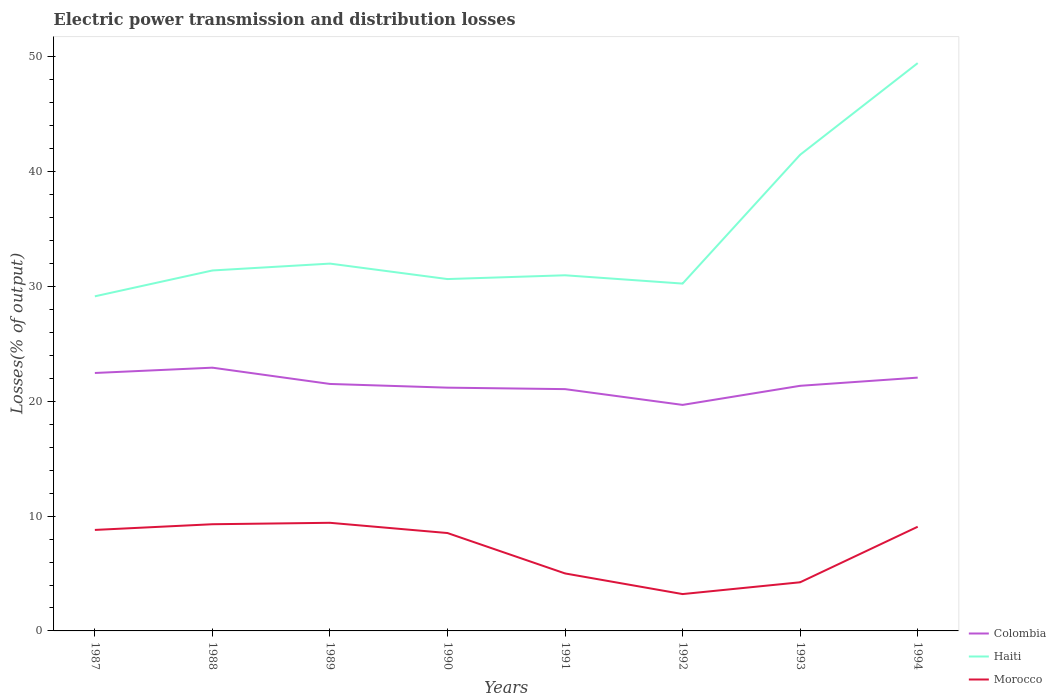Does the line corresponding to Morocco intersect with the line corresponding to Colombia?
Offer a terse response. No. Across all years, what is the maximum electric power transmission and distribution losses in Colombia?
Offer a terse response. 19.69. In which year was the electric power transmission and distribution losses in Haiti maximum?
Your answer should be compact. 1987. What is the total electric power transmission and distribution losses in Morocco in the graph?
Make the answer very short. 6.21. What is the difference between the highest and the second highest electric power transmission and distribution losses in Colombia?
Make the answer very short. 3.24. What is the difference between the highest and the lowest electric power transmission and distribution losses in Morocco?
Your answer should be compact. 5. Is the electric power transmission and distribution losses in Colombia strictly greater than the electric power transmission and distribution losses in Haiti over the years?
Ensure brevity in your answer.  Yes. How many lines are there?
Your answer should be compact. 3. How many years are there in the graph?
Provide a short and direct response. 8. What is the difference between two consecutive major ticks on the Y-axis?
Keep it short and to the point. 10. Are the values on the major ticks of Y-axis written in scientific E-notation?
Provide a short and direct response. No. How many legend labels are there?
Your answer should be very brief. 3. What is the title of the graph?
Your response must be concise. Electric power transmission and distribution losses. What is the label or title of the X-axis?
Ensure brevity in your answer.  Years. What is the label or title of the Y-axis?
Provide a short and direct response. Losses(% of output). What is the Losses(% of output) in Colombia in 1987?
Provide a succinct answer. 22.47. What is the Losses(% of output) of Haiti in 1987?
Offer a very short reply. 29.15. What is the Losses(% of output) of Morocco in 1987?
Your answer should be very brief. 8.8. What is the Losses(% of output) of Colombia in 1988?
Ensure brevity in your answer.  22.93. What is the Losses(% of output) in Haiti in 1988?
Ensure brevity in your answer.  31.4. What is the Losses(% of output) of Morocco in 1988?
Offer a very short reply. 9.29. What is the Losses(% of output) in Colombia in 1989?
Provide a succinct answer. 21.52. What is the Losses(% of output) of Haiti in 1989?
Keep it short and to the point. 32. What is the Losses(% of output) of Morocco in 1989?
Offer a terse response. 9.42. What is the Losses(% of output) of Colombia in 1990?
Offer a terse response. 21.19. What is the Losses(% of output) in Haiti in 1990?
Your answer should be very brief. 30.65. What is the Losses(% of output) in Morocco in 1990?
Provide a succinct answer. 8.53. What is the Losses(% of output) in Colombia in 1991?
Make the answer very short. 21.07. What is the Losses(% of output) of Haiti in 1991?
Provide a short and direct response. 30.98. What is the Losses(% of output) in Morocco in 1991?
Your answer should be very brief. 5.01. What is the Losses(% of output) in Colombia in 1992?
Your answer should be compact. 19.69. What is the Losses(% of output) of Haiti in 1992?
Keep it short and to the point. 30.26. What is the Losses(% of output) in Morocco in 1992?
Your answer should be compact. 3.21. What is the Losses(% of output) of Colombia in 1993?
Ensure brevity in your answer.  21.35. What is the Losses(% of output) in Haiti in 1993?
Your response must be concise. 41.48. What is the Losses(% of output) in Morocco in 1993?
Provide a short and direct response. 4.24. What is the Losses(% of output) in Colombia in 1994?
Your answer should be compact. 22.07. What is the Losses(% of output) of Haiti in 1994?
Provide a succinct answer. 49.47. What is the Losses(% of output) of Morocco in 1994?
Give a very brief answer. 9.08. Across all years, what is the maximum Losses(% of output) in Colombia?
Give a very brief answer. 22.93. Across all years, what is the maximum Losses(% of output) of Haiti?
Your answer should be compact. 49.47. Across all years, what is the maximum Losses(% of output) in Morocco?
Keep it short and to the point. 9.42. Across all years, what is the minimum Losses(% of output) of Colombia?
Your response must be concise. 19.69. Across all years, what is the minimum Losses(% of output) in Haiti?
Your answer should be very brief. 29.15. Across all years, what is the minimum Losses(% of output) of Morocco?
Provide a succinct answer. 3.21. What is the total Losses(% of output) of Colombia in the graph?
Your answer should be very brief. 172.29. What is the total Losses(% of output) of Haiti in the graph?
Give a very brief answer. 275.4. What is the total Losses(% of output) of Morocco in the graph?
Make the answer very short. 57.57. What is the difference between the Losses(% of output) in Colombia in 1987 and that in 1988?
Offer a very short reply. -0.46. What is the difference between the Losses(% of output) in Haiti in 1987 and that in 1988?
Your answer should be compact. -2.25. What is the difference between the Losses(% of output) in Morocco in 1987 and that in 1988?
Your answer should be compact. -0.5. What is the difference between the Losses(% of output) of Colombia in 1987 and that in 1989?
Offer a terse response. 0.96. What is the difference between the Losses(% of output) in Haiti in 1987 and that in 1989?
Make the answer very short. -2.85. What is the difference between the Losses(% of output) of Morocco in 1987 and that in 1989?
Keep it short and to the point. -0.62. What is the difference between the Losses(% of output) of Colombia in 1987 and that in 1990?
Provide a short and direct response. 1.28. What is the difference between the Losses(% of output) in Haiti in 1987 and that in 1990?
Offer a terse response. -1.5. What is the difference between the Losses(% of output) of Morocco in 1987 and that in 1990?
Provide a short and direct response. 0.27. What is the difference between the Losses(% of output) in Colombia in 1987 and that in 1991?
Ensure brevity in your answer.  1.41. What is the difference between the Losses(% of output) in Haiti in 1987 and that in 1991?
Provide a succinct answer. -1.83. What is the difference between the Losses(% of output) in Morocco in 1987 and that in 1991?
Make the answer very short. 3.79. What is the difference between the Losses(% of output) in Colombia in 1987 and that in 1992?
Give a very brief answer. 2.78. What is the difference between the Losses(% of output) in Haiti in 1987 and that in 1992?
Your response must be concise. -1.11. What is the difference between the Losses(% of output) in Morocco in 1987 and that in 1992?
Your answer should be compact. 5.59. What is the difference between the Losses(% of output) in Colombia in 1987 and that in 1993?
Keep it short and to the point. 1.12. What is the difference between the Losses(% of output) in Haiti in 1987 and that in 1993?
Make the answer very short. -12.33. What is the difference between the Losses(% of output) in Morocco in 1987 and that in 1993?
Your response must be concise. 4.56. What is the difference between the Losses(% of output) in Colombia in 1987 and that in 1994?
Offer a very short reply. 0.4. What is the difference between the Losses(% of output) of Haiti in 1987 and that in 1994?
Give a very brief answer. -20.32. What is the difference between the Losses(% of output) of Morocco in 1987 and that in 1994?
Ensure brevity in your answer.  -0.28. What is the difference between the Losses(% of output) in Colombia in 1988 and that in 1989?
Your answer should be compact. 1.42. What is the difference between the Losses(% of output) in Haiti in 1988 and that in 1989?
Your answer should be very brief. -0.6. What is the difference between the Losses(% of output) of Morocco in 1988 and that in 1989?
Provide a succinct answer. -0.12. What is the difference between the Losses(% of output) of Colombia in 1988 and that in 1990?
Provide a succinct answer. 1.74. What is the difference between the Losses(% of output) in Haiti in 1988 and that in 1990?
Offer a very short reply. 0.75. What is the difference between the Losses(% of output) of Morocco in 1988 and that in 1990?
Your response must be concise. 0.77. What is the difference between the Losses(% of output) of Colombia in 1988 and that in 1991?
Give a very brief answer. 1.87. What is the difference between the Losses(% of output) of Haiti in 1988 and that in 1991?
Your response must be concise. 0.42. What is the difference between the Losses(% of output) of Morocco in 1988 and that in 1991?
Keep it short and to the point. 4.29. What is the difference between the Losses(% of output) in Colombia in 1988 and that in 1992?
Make the answer very short. 3.24. What is the difference between the Losses(% of output) of Haiti in 1988 and that in 1992?
Your answer should be very brief. 1.14. What is the difference between the Losses(% of output) in Morocco in 1988 and that in 1992?
Provide a short and direct response. 6.08. What is the difference between the Losses(% of output) in Colombia in 1988 and that in 1993?
Your response must be concise. 1.58. What is the difference between the Losses(% of output) of Haiti in 1988 and that in 1993?
Your response must be concise. -10.08. What is the difference between the Losses(% of output) of Morocco in 1988 and that in 1993?
Offer a terse response. 5.06. What is the difference between the Losses(% of output) in Colombia in 1988 and that in 1994?
Offer a terse response. 0.87. What is the difference between the Losses(% of output) in Haiti in 1988 and that in 1994?
Give a very brief answer. -18.06. What is the difference between the Losses(% of output) in Morocco in 1988 and that in 1994?
Offer a very short reply. 0.22. What is the difference between the Losses(% of output) in Colombia in 1989 and that in 1990?
Give a very brief answer. 0.32. What is the difference between the Losses(% of output) of Haiti in 1989 and that in 1990?
Provide a short and direct response. 1.35. What is the difference between the Losses(% of output) in Morocco in 1989 and that in 1990?
Offer a very short reply. 0.89. What is the difference between the Losses(% of output) of Colombia in 1989 and that in 1991?
Your answer should be very brief. 0.45. What is the difference between the Losses(% of output) in Haiti in 1989 and that in 1991?
Your response must be concise. 1.02. What is the difference between the Losses(% of output) in Morocco in 1989 and that in 1991?
Make the answer very short. 4.41. What is the difference between the Losses(% of output) in Colombia in 1989 and that in 1992?
Offer a very short reply. 1.82. What is the difference between the Losses(% of output) of Haiti in 1989 and that in 1992?
Your response must be concise. 1.74. What is the difference between the Losses(% of output) of Morocco in 1989 and that in 1992?
Offer a terse response. 6.21. What is the difference between the Losses(% of output) in Colombia in 1989 and that in 1993?
Your answer should be compact. 0.16. What is the difference between the Losses(% of output) of Haiti in 1989 and that in 1993?
Ensure brevity in your answer.  -9.48. What is the difference between the Losses(% of output) in Morocco in 1989 and that in 1993?
Offer a terse response. 5.18. What is the difference between the Losses(% of output) in Colombia in 1989 and that in 1994?
Your answer should be very brief. -0.55. What is the difference between the Losses(% of output) of Haiti in 1989 and that in 1994?
Ensure brevity in your answer.  -17.47. What is the difference between the Losses(% of output) in Morocco in 1989 and that in 1994?
Keep it short and to the point. 0.34. What is the difference between the Losses(% of output) of Colombia in 1990 and that in 1991?
Offer a very short reply. 0.13. What is the difference between the Losses(% of output) of Haiti in 1990 and that in 1991?
Offer a very short reply. -0.33. What is the difference between the Losses(% of output) in Morocco in 1990 and that in 1991?
Provide a succinct answer. 3.52. What is the difference between the Losses(% of output) in Colombia in 1990 and that in 1992?
Make the answer very short. 1.5. What is the difference between the Losses(% of output) in Haiti in 1990 and that in 1992?
Provide a succinct answer. 0.39. What is the difference between the Losses(% of output) in Morocco in 1990 and that in 1992?
Make the answer very short. 5.32. What is the difference between the Losses(% of output) of Colombia in 1990 and that in 1993?
Provide a short and direct response. -0.16. What is the difference between the Losses(% of output) in Haiti in 1990 and that in 1993?
Provide a succinct answer. -10.83. What is the difference between the Losses(% of output) in Morocco in 1990 and that in 1993?
Ensure brevity in your answer.  4.29. What is the difference between the Losses(% of output) of Colombia in 1990 and that in 1994?
Make the answer very short. -0.88. What is the difference between the Losses(% of output) of Haiti in 1990 and that in 1994?
Provide a succinct answer. -18.81. What is the difference between the Losses(% of output) of Morocco in 1990 and that in 1994?
Offer a very short reply. -0.55. What is the difference between the Losses(% of output) of Colombia in 1991 and that in 1992?
Your answer should be very brief. 1.37. What is the difference between the Losses(% of output) in Haiti in 1991 and that in 1992?
Give a very brief answer. 0.72. What is the difference between the Losses(% of output) of Morocco in 1991 and that in 1992?
Your response must be concise. 1.8. What is the difference between the Losses(% of output) of Colombia in 1991 and that in 1993?
Your response must be concise. -0.29. What is the difference between the Losses(% of output) of Haiti in 1991 and that in 1993?
Provide a succinct answer. -10.5. What is the difference between the Losses(% of output) in Morocco in 1991 and that in 1993?
Make the answer very short. 0.77. What is the difference between the Losses(% of output) of Colombia in 1991 and that in 1994?
Make the answer very short. -1. What is the difference between the Losses(% of output) of Haiti in 1991 and that in 1994?
Your response must be concise. -18.48. What is the difference between the Losses(% of output) in Morocco in 1991 and that in 1994?
Your answer should be very brief. -4.07. What is the difference between the Losses(% of output) of Colombia in 1992 and that in 1993?
Your answer should be compact. -1.66. What is the difference between the Losses(% of output) in Haiti in 1992 and that in 1993?
Your response must be concise. -11.22. What is the difference between the Losses(% of output) of Morocco in 1992 and that in 1993?
Offer a terse response. -1.03. What is the difference between the Losses(% of output) of Colombia in 1992 and that in 1994?
Offer a very short reply. -2.38. What is the difference between the Losses(% of output) in Haiti in 1992 and that in 1994?
Keep it short and to the point. -19.21. What is the difference between the Losses(% of output) in Morocco in 1992 and that in 1994?
Offer a very short reply. -5.87. What is the difference between the Losses(% of output) of Colombia in 1993 and that in 1994?
Offer a terse response. -0.71. What is the difference between the Losses(% of output) of Haiti in 1993 and that in 1994?
Provide a short and direct response. -7.98. What is the difference between the Losses(% of output) of Morocco in 1993 and that in 1994?
Provide a short and direct response. -4.84. What is the difference between the Losses(% of output) in Colombia in 1987 and the Losses(% of output) in Haiti in 1988?
Your response must be concise. -8.93. What is the difference between the Losses(% of output) of Colombia in 1987 and the Losses(% of output) of Morocco in 1988?
Your response must be concise. 13.18. What is the difference between the Losses(% of output) of Haiti in 1987 and the Losses(% of output) of Morocco in 1988?
Your answer should be compact. 19.86. What is the difference between the Losses(% of output) in Colombia in 1987 and the Losses(% of output) in Haiti in 1989?
Make the answer very short. -9.53. What is the difference between the Losses(% of output) in Colombia in 1987 and the Losses(% of output) in Morocco in 1989?
Offer a terse response. 13.05. What is the difference between the Losses(% of output) of Haiti in 1987 and the Losses(% of output) of Morocco in 1989?
Your response must be concise. 19.73. What is the difference between the Losses(% of output) in Colombia in 1987 and the Losses(% of output) in Haiti in 1990?
Ensure brevity in your answer.  -8.18. What is the difference between the Losses(% of output) in Colombia in 1987 and the Losses(% of output) in Morocco in 1990?
Provide a short and direct response. 13.94. What is the difference between the Losses(% of output) of Haiti in 1987 and the Losses(% of output) of Morocco in 1990?
Make the answer very short. 20.62. What is the difference between the Losses(% of output) in Colombia in 1987 and the Losses(% of output) in Haiti in 1991?
Offer a terse response. -8.51. What is the difference between the Losses(% of output) in Colombia in 1987 and the Losses(% of output) in Morocco in 1991?
Offer a terse response. 17.46. What is the difference between the Losses(% of output) of Haiti in 1987 and the Losses(% of output) of Morocco in 1991?
Provide a succinct answer. 24.14. What is the difference between the Losses(% of output) in Colombia in 1987 and the Losses(% of output) in Haiti in 1992?
Provide a succinct answer. -7.79. What is the difference between the Losses(% of output) in Colombia in 1987 and the Losses(% of output) in Morocco in 1992?
Offer a very short reply. 19.26. What is the difference between the Losses(% of output) in Haiti in 1987 and the Losses(% of output) in Morocco in 1992?
Ensure brevity in your answer.  25.94. What is the difference between the Losses(% of output) of Colombia in 1987 and the Losses(% of output) of Haiti in 1993?
Your answer should be very brief. -19.01. What is the difference between the Losses(% of output) of Colombia in 1987 and the Losses(% of output) of Morocco in 1993?
Ensure brevity in your answer.  18.23. What is the difference between the Losses(% of output) in Haiti in 1987 and the Losses(% of output) in Morocco in 1993?
Give a very brief answer. 24.91. What is the difference between the Losses(% of output) of Colombia in 1987 and the Losses(% of output) of Haiti in 1994?
Ensure brevity in your answer.  -26.99. What is the difference between the Losses(% of output) of Colombia in 1987 and the Losses(% of output) of Morocco in 1994?
Provide a short and direct response. 13.4. What is the difference between the Losses(% of output) in Haiti in 1987 and the Losses(% of output) in Morocco in 1994?
Offer a terse response. 20.07. What is the difference between the Losses(% of output) of Colombia in 1988 and the Losses(% of output) of Haiti in 1989?
Ensure brevity in your answer.  -9.07. What is the difference between the Losses(% of output) of Colombia in 1988 and the Losses(% of output) of Morocco in 1989?
Offer a very short reply. 13.51. What is the difference between the Losses(% of output) of Haiti in 1988 and the Losses(% of output) of Morocco in 1989?
Provide a succinct answer. 21.98. What is the difference between the Losses(% of output) of Colombia in 1988 and the Losses(% of output) of Haiti in 1990?
Your response must be concise. -7.72. What is the difference between the Losses(% of output) of Colombia in 1988 and the Losses(% of output) of Morocco in 1990?
Offer a very short reply. 14.41. What is the difference between the Losses(% of output) of Haiti in 1988 and the Losses(% of output) of Morocco in 1990?
Provide a succinct answer. 22.87. What is the difference between the Losses(% of output) in Colombia in 1988 and the Losses(% of output) in Haiti in 1991?
Offer a terse response. -8.05. What is the difference between the Losses(% of output) of Colombia in 1988 and the Losses(% of output) of Morocco in 1991?
Keep it short and to the point. 17.93. What is the difference between the Losses(% of output) of Haiti in 1988 and the Losses(% of output) of Morocco in 1991?
Keep it short and to the point. 26.39. What is the difference between the Losses(% of output) in Colombia in 1988 and the Losses(% of output) in Haiti in 1992?
Your response must be concise. -7.33. What is the difference between the Losses(% of output) in Colombia in 1988 and the Losses(% of output) in Morocco in 1992?
Ensure brevity in your answer.  19.72. What is the difference between the Losses(% of output) in Haiti in 1988 and the Losses(% of output) in Morocco in 1992?
Keep it short and to the point. 28.19. What is the difference between the Losses(% of output) in Colombia in 1988 and the Losses(% of output) in Haiti in 1993?
Provide a succinct answer. -18.55. What is the difference between the Losses(% of output) of Colombia in 1988 and the Losses(% of output) of Morocco in 1993?
Your answer should be compact. 18.7. What is the difference between the Losses(% of output) of Haiti in 1988 and the Losses(% of output) of Morocco in 1993?
Offer a terse response. 27.16. What is the difference between the Losses(% of output) of Colombia in 1988 and the Losses(% of output) of Haiti in 1994?
Your answer should be very brief. -26.53. What is the difference between the Losses(% of output) of Colombia in 1988 and the Losses(% of output) of Morocco in 1994?
Keep it short and to the point. 13.86. What is the difference between the Losses(% of output) in Haiti in 1988 and the Losses(% of output) in Morocco in 1994?
Provide a short and direct response. 22.33. What is the difference between the Losses(% of output) of Colombia in 1989 and the Losses(% of output) of Haiti in 1990?
Provide a succinct answer. -9.14. What is the difference between the Losses(% of output) in Colombia in 1989 and the Losses(% of output) in Morocco in 1990?
Your answer should be compact. 12.99. What is the difference between the Losses(% of output) in Haiti in 1989 and the Losses(% of output) in Morocco in 1990?
Your response must be concise. 23.47. What is the difference between the Losses(% of output) of Colombia in 1989 and the Losses(% of output) of Haiti in 1991?
Offer a very short reply. -9.47. What is the difference between the Losses(% of output) of Colombia in 1989 and the Losses(% of output) of Morocco in 1991?
Provide a short and direct response. 16.51. What is the difference between the Losses(% of output) in Haiti in 1989 and the Losses(% of output) in Morocco in 1991?
Keep it short and to the point. 26.99. What is the difference between the Losses(% of output) in Colombia in 1989 and the Losses(% of output) in Haiti in 1992?
Keep it short and to the point. -8.74. What is the difference between the Losses(% of output) in Colombia in 1989 and the Losses(% of output) in Morocco in 1992?
Provide a short and direct response. 18.31. What is the difference between the Losses(% of output) of Haiti in 1989 and the Losses(% of output) of Morocco in 1992?
Offer a very short reply. 28.79. What is the difference between the Losses(% of output) of Colombia in 1989 and the Losses(% of output) of Haiti in 1993?
Your answer should be compact. -19.97. What is the difference between the Losses(% of output) of Colombia in 1989 and the Losses(% of output) of Morocco in 1993?
Your answer should be compact. 17.28. What is the difference between the Losses(% of output) of Haiti in 1989 and the Losses(% of output) of Morocco in 1993?
Your answer should be very brief. 27.76. What is the difference between the Losses(% of output) of Colombia in 1989 and the Losses(% of output) of Haiti in 1994?
Give a very brief answer. -27.95. What is the difference between the Losses(% of output) of Colombia in 1989 and the Losses(% of output) of Morocco in 1994?
Your response must be concise. 12.44. What is the difference between the Losses(% of output) in Haiti in 1989 and the Losses(% of output) in Morocco in 1994?
Offer a terse response. 22.92. What is the difference between the Losses(% of output) of Colombia in 1990 and the Losses(% of output) of Haiti in 1991?
Give a very brief answer. -9.79. What is the difference between the Losses(% of output) in Colombia in 1990 and the Losses(% of output) in Morocco in 1991?
Ensure brevity in your answer.  16.18. What is the difference between the Losses(% of output) of Haiti in 1990 and the Losses(% of output) of Morocco in 1991?
Provide a short and direct response. 25.65. What is the difference between the Losses(% of output) of Colombia in 1990 and the Losses(% of output) of Haiti in 1992?
Provide a short and direct response. -9.07. What is the difference between the Losses(% of output) of Colombia in 1990 and the Losses(% of output) of Morocco in 1992?
Offer a very short reply. 17.98. What is the difference between the Losses(% of output) in Haiti in 1990 and the Losses(% of output) in Morocco in 1992?
Offer a very short reply. 27.44. What is the difference between the Losses(% of output) of Colombia in 1990 and the Losses(% of output) of Haiti in 1993?
Make the answer very short. -20.29. What is the difference between the Losses(% of output) in Colombia in 1990 and the Losses(% of output) in Morocco in 1993?
Make the answer very short. 16.95. What is the difference between the Losses(% of output) in Haiti in 1990 and the Losses(% of output) in Morocco in 1993?
Your answer should be compact. 26.42. What is the difference between the Losses(% of output) in Colombia in 1990 and the Losses(% of output) in Haiti in 1994?
Provide a short and direct response. -28.27. What is the difference between the Losses(% of output) in Colombia in 1990 and the Losses(% of output) in Morocco in 1994?
Provide a short and direct response. 12.12. What is the difference between the Losses(% of output) of Haiti in 1990 and the Losses(% of output) of Morocco in 1994?
Offer a terse response. 21.58. What is the difference between the Losses(% of output) of Colombia in 1991 and the Losses(% of output) of Haiti in 1992?
Your answer should be compact. -9.19. What is the difference between the Losses(% of output) of Colombia in 1991 and the Losses(% of output) of Morocco in 1992?
Offer a very short reply. 17.85. What is the difference between the Losses(% of output) in Haiti in 1991 and the Losses(% of output) in Morocco in 1992?
Your answer should be very brief. 27.77. What is the difference between the Losses(% of output) of Colombia in 1991 and the Losses(% of output) of Haiti in 1993?
Offer a terse response. -20.42. What is the difference between the Losses(% of output) in Colombia in 1991 and the Losses(% of output) in Morocco in 1993?
Make the answer very short. 16.83. What is the difference between the Losses(% of output) of Haiti in 1991 and the Losses(% of output) of Morocco in 1993?
Your answer should be compact. 26.74. What is the difference between the Losses(% of output) in Colombia in 1991 and the Losses(% of output) in Haiti in 1994?
Give a very brief answer. -28.4. What is the difference between the Losses(% of output) of Colombia in 1991 and the Losses(% of output) of Morocco in 1994?
Make the answer very short. 11.99. What is the difference between the Losses(% of output) of Haiti in 1991 and the Losses(% of output) of Morocco in 1994?
Ensure brevity in your answer.  21.91. What is the difference between the Losses(% of output) of Colombia in 1992 and the Losses(% of output) of Haiti in 1993?
Offer a very short reply. -21.79. What is the difference between the Losses(% of output) of Colombia in 1992 and the Losses(% of output) of Morocco in 1993?
Offer a very short reply. 15.45. What is the difference between the Losses(% of output) of Haiti in 1992 and the Losses(% of output) of Morocco in 1993?
Make the answer very short. 26.02. What is the difference between the Losses(% of output) of Colombia in 1992 and the Losses(% of output) of Haiti in 1994?
Your answer should be very brief. -29.78. What is the difference between the Losses(% of output) in Colombia in 1992 and the Losses(% of output) in Morocco in 1994?
Give a very brief answer. 10.62. What is the difference between the Losses(% of output) in Haiti in 1992 and the Losses(% of output) in Morocco in 1994?
Your answer should be compact. 21.18. What is the difference between the Losses(% of output) of Colombia in 1993 and the Losses(% of output) of Haiti in 1994?
Your answer should be compact. -28.11. What is the difference between the Losses(% of output) in Colombia in 1993 and the Losses(% of output) in Morocco in 1994?
Your response must be concise. 12.28. What is the difference between the Losses(% of output) in Haiti in 1993 and the Losses(% of output) in Morocco in 1994?
Make the answer very short. 32.41. What is the average Losses(% of output) of Colombia per year?
Offer a terse response. 21.54. What is the average Losses(% of output) of Haiti per year?
Provide a succinct answer. 34.42. What is the average Losses(% of output) of Morocco per year?
Offer a terse response. 7.2. In the year 1987, what is the difference between the Losses(% of output) in Colombia and Losses(% of output) in Haiti?
Give a very brief answer. -6.68. In the year 1987, what is the difference between the Losses(% of output) of Colombia and Losses(% of output) of Morocco?
Your answer should be very brief. 13.67. In the year 1987, what is the difference between the Losses(% of output) of Haiti and Losses(% of output) of Morocco?
Offer a very short reply. 20.35. In the year 1988, what is the difference between the Losses(% of output) of Colombia and Losses(% of output) of Haiti?
Provide a succinct answer. -8.47. In the year 1988, what is the difference between the Losses(% of output) of Colombia and Losses(% of output) of Morocco?
Offer a very short reply. 13.64. In the year 1988, what is the difference between the Losses(% of output) in Haiti and Losses(% of output) in Morocco?
Ensure brevity in your answer.  22.11. In the year 1989, what is the difference between the Losses(% of output) of Colombia and Losses(% of output) of Haiti?
Offer a terse response. -10.48. In the year 1989, what is the difference between the Losses(% of output) in Colombia and Losses(% of output) in Morocco?
Your response must be concise. 12.1. In the year 1989, what is the difference between the Losses(% of output) in Haiti and Losses(% of output) in Morocco?
Provide a succinct answer. 22.58. In the year 1990, what is the difference between the Losses(% of output) of Colombia and Losses(% of output) of Haiti?
Make the answer very short. -9.46. In the year 1990, what is the difference between the Losses(% of output) in Colombia and Losses(% of output) in Morocco?
Provide a succinct answer. 12.67. In the year 1990, what is the difference between the Losses(% of output) in Haiti and Losses(% of output) in Morocco?
Provide a succinct answer. 22.13. In the year 1991, what is the difference between the Losses(% of output) in Colombia and Losses(% of output) in Haiti?
Your response must be concise. -9.92. In the year 1991, what is the difference between the Losses(% of output) of Colombia and Losses(% of output) of Morocco?
Your answer should be very brief. 16.06. In the year 1991, what is the difference between the Losses(% of output) of Haiti and Losses(% of output) of Morocco?
Make the answer very short. 25.97. In the year 1992, what is the difference between the Losses(% of output) in Colombia and Losses(% of output) in Haiti?
Your answer should be very brief. -10.57. In the year 1992, what is the difference between the Losses(% of output) in Colombia and Losses(% of output) in Morocco?
Your response must be concise. 16.48. In the year 1992, what is the difference between the Losses(% of output) in Haiti and Losses(% of output) in Morocco?
Your answer should be compact. 27.05. In the year 1993, what is the difference between the Losses(% of output) in Colombia and Losses(% of output) in Haiti?
Provide a short and direct response. -20.13. In the year 1993, what is the difference between the Losses(% of output) in Colombia and Losses(% of output) in Morocco?
Your answer should be very brief. 17.12. In the year 1993, what is the difference between the Losses(% of output) in Haiti and Losses(% of output) in Morocco?
Ensure brevity in your answer.  37.25. In the year 1994, what is the difference between the Losses(% of output) in Colombia and Losses(% of output) in Haiti?
Provide a short and direct response. -27.4. In the year 1994, what is the difference between the Losses(% of output) in Colombia and Losses(% of output) in Morocco?
Give a very brief answer. 12.99. In the year 1994, what is the difference between the Losses(% of output) of Haiti and Losses(% of output) of Morocco?
Ensure brevity in your answer.  40.39. What is the ratio of the Losses(% of output) in Colombia in 1987 to that in 1988?
Offer a very short reply. 0.98. What is the ratio of the Losses(% of output) in Haiti in 1987 to that in 1988?
Offer a terse response. 0.93. What is the ratio of the Losses(% of output) in Morocco in 1987 to that in 1988?
Your answer should be very brief. 0.95. What is the ratio of the Losses(% of output) of Colombia in 1987 to that in 1989?
Your answer should be very brief. 1.04. What is the ratio of the Losses(% of output) in Haiti in 1987 to that in 1989?
Provide a succinct answer. 0.91. What is the ratio of the Losses(% of output) of Morocco in 1987 to that in 1989?
Provide a succinct answer. 0.93. What is the ratio of the Losses(% of output) in Colombia in 1987 to that in 1990?
Keep it short and to the point. 1.06. What is the ratio of the Losses(% of output) of Haiti in 1987 to that in 1990?
Offer a terse response. 0.95. What is the ratio of the Losses(% of output) in Morocco in 1987 to that in 1990?
Your answer should be very brief. 1.03. What is the ratio of the Losses(% of output) of Colombia in 1987 to that in 1991?
Offer a terse response. 1.07. What is the ratio of the Losses(% of output) in Haiti in 1987 to that in 1991?
Your response must be concise. 0.94. What is the ratio of the Losses(% of output) of Morocco in 1987 to that in 1991?
Give a very brief answer. 1.76. What is the ratio of the Losses(% of output) in Colombia in 1987 to that in 1992?
Your response must be concise. 1.14. What is the ratio of the Losses(% of output) in Haiti in 1987 to that in 1992?
Your answer should be very brief. 0.96. What is the ratio of the Losses(% of output) in Morocco in 1987 to that in 1992?
Keep it short and to the point. 2.74. What is the ratio of the Losses(% of output) of Colombia in 1987 to that in 1993?
Your answer should be compact. 1.05. What is the ratio of the Losses(% of output) of Haiti in 1987 to that in 1993?
Make the answer very short. 0.7. What is the ratio of the Losses(% of output) of Morocco in 1987 to that in 1993?
Offer a terse response. 2.08. What is the ratio of the Losses(% of output) of Colombia in 1987 to that in 1994?
Your response must be concise. 1.02. What is the ratio of the Losses(% of output) of Haiti in 1987 to that in 1994?
Your answer should be compact. 0.59. What is the ratio of the Losses(% of output) in Morocco in 1987 to that in 1994?
Your answer should be compact. 0.97. What is the ratio of the Losses(% of output) of Colombia in 1988 to that in 1989?
Your response must be concise. 1.07. What is the ratio of the Losses(% of output) of Haiti in 1988 to that in 1989?
Keep it short and to the point. 0.98. What is the ratio of the Losses(% of output) in Morocco in 1988 to that in 1989?
Provide a succinct answer. 0.99. What is the ratio of the Losses(% of output) in Colombia in 1988 to that in 1990?
Your answer should be compact. 1.08. What is the ratio of the Losses(% of output) of Haiti in 1988 to that in 1990?
Your response must be concise. 1.02. What is the ratio of the Losses(% of output) of Morocco in 1988 to that in 1990?
Provide a short and direct response. 1.09. What is the ratio of the Losses(% of output) in Colombia in 1988 to that in 1991?
Make the answer very short. 1.09. What is the ratio of the Losses(% of output) in Haiti in 1988 to that in 1991?
Keep it short and to the point. 1.01. What is the ratio of the Losses(% of output) of Morocco in 1988 to that in 1991?
Ensure brevity in your answer.  1.86. What is the ratio of the Losses(% of output) in Colombia in 1988 to that in 1992?
Provide a succinct answer. 1.16. What is the ratio of the Losses(% of output) in Haiti in 1988 to that in 1992?
Offer a terse response. 1.04. What is the ratio of the Losses(% of output) in Morocco in 1988 to that in 1992?
Ensure brevity in your answer.  2.9. What is the ratio of the Losses(% of output) in Colombia in 1988 to that in 1993?
Offer a terse response. 1.07. What is the ratio of the Losses(% of output) in Haiti in 1988 to that in 1993?
Give a very brief answer. 0.76. What is the ratio of the Losses(% of output) in Morocco in 1988 to that in 1993?
Give a very brief answer. 2.19. What is the ratio of the Losses(% of output) of Colombia in 1988 to that in 1994?
Give a very brief answer. 1.04. What is the ratio of the Losses(% of output) of Haiti in 1988 to that in 1994?
Offer a terse response. 0.63. What is the ratio of the Losses(% of output) of Morocco in 1988 to that in 1994?
Ensure brevity in your answer.  1.02. What is the ratio of the Losses(% of output) of Colombia in 1989 to that in 1990?
Give a very brief answer. 1.02. What is the ratio of the Losses(% of output) in Haiti in 1989 to that in 1990?
Provide a succinct answer. 1.04. What is the ratio of the Losses(% of output) in Morocco in 1989 to that in 1990?
Your answer should be very brief. 1.1. What is the ratio of the Losses(% of output) of Colombia in 1989 to that in 1991?
Your answer should be compact. 1.02. What is the ratio of the Losses(% of output) of Haiti in 1989 to that in 1991?
Make the answer very short. 1.03. What is the ratio of the Losses(% of output) in Morocco in 1989 to that in 1991?
Give a very brief answer. 1.88. What is the ratio of the Losses(% of output) in Colombia in 1989 to that in 1992?
Provide a succinct answer. 1.09. What is the ratio of the Losses(% of output) in Haiti in 1989 to that in 1992?
Give a very brief answer. 1.06. What is the ratio of the Losses(% of output) in Morocco in 1989 to that in 1992?
Provide a short and direct response. 2.93. What is the ratio of the Losses(% of output) of Colombia in 1989 to that in 1993?
Give a very brief answer. 1.01. What is the ratio of the Losses(% of output) of Haiti in 1989 to that in 1993?
Your response must be concise. 0.77. What is the ratio of the Losses(% of output) of Morocco in 1989 to that in 1993?
Offer a very short reply. 2.22. What is the ratio of the Losses(% of output) in Colombia in 1989 to that in 1994?
Provide a short and direct response. 0.97. What is the ratio of the Losses(% of output) of Haiti in 1989 to that in 1994?
Your answer should be very brief. 0.65. What is the ratio of the Losses(% of output) of Morocco in 1989 to that in 1994?
Your response must be concise. 1.04. What is the ratio of the Losses(% of output) of Colombia in 1990 to that in 1991?
Offer a very short reply. 1.01. What is the ratio of the Losses(% of output) in Haiti in 1990 to that in 1991?
Your answer should be compact. 0.99. What is the ratio of the Losses(% of output) of Morocco in 1990 to that in 1991?
Your response must be concise. 1.7. What is the ratio of the Losses(% of output) in Colombia in 1990 to that in 1992?
Your answer should be compact. 1.08. What is the ratio of the Losses(% of output) of Haiti in 1990 to that in 1992?
Your answer should be compact. 1.01. What is the ratio of the Losses(% of output) of Morocco in 1990 to that in 1992?
Your answer should be compact. 2.66. What is the ratio of the Losses(% of output) in Colombia in 1990 to that in 1993?
Your answer should be very brief. 0.99. What is the ratio of the Losses(% of output) in Haiti in 1990 to that in 1993?
Keep it short and to the point. 0.74. What is the ratio of the Losses(% of output) in Morocco in 1990 to that in 1993?
Offer a terse response. 2.01. What is the ratio of the Losses(% of output) of Colombia in 1990 to that in 1994?
Your answer should be very brief. 0.96. What is the ratio of the Losses(% of output) of Haiti in 1990 to that in 1994?
Your response must be concise. 0.62. What is the ratio of the Losses(% of output) of Morocco in 1990 to that in 1994?
Ensure brevity in your answer.  0.94. What is the ratio of the Losses(% of output) in Colombia in 1991 to that in 1992?
Make the answer very short. 1.07. What is the ratio of the Losses(% of output) in Haiti in 1991 to that in 1992?
Provide a short and direct response. 1.02. What is the ratio of the Losses(% of output) in Morocco in 1991 to that in 1992?
Your answer should be compact. 1.56. What is the ratio of the Losses(% of output) in Colombia in 1991 to that in 1993?
Provide a succinct answer. 0.99. What is the ratio of the Losses(% of output) of Haiti in 1991 to that in 1993?
Make the answer very short. 0.75. What is the ratio of the Losses(% of output) in Morocco in 1991 to that in 1993?
Provide a succinct answer. 1.18. What is the ratio of the Losses(% of output) in Colombia in 1991 to that in 1994?
Give a very brief answer. 0.95. What is the ratio of the Losses(% of output) of Haiti in 1991 to that in 1994?
Keep it short and to the point. 0.63. What is the ratio of the Losses(% of output) in Morocco in 1991 to that in 1994?
Provide a short and direct response. 0.55. What is the ratio of the Losses(% of output) of Colombia in 1992 to that in 1993?
Offer a very short reply. 0.92. What is the ratio of the Losses(% of output) of Haiti in 1992 to that in 1993?
Your answer should be very brief. 0.73. What is the ratio of the Losses(% of output) of Morocco in 1992 to that in 1993?
Make the answer very short. 0.76. What is the ratio of the Losses(% of output) of Colombia in 1992 to that in 1994?
Keep it short and to the point. 0.89. What is the ratio of the Losses(% of output) in Haiti in 1992 to that in 1994?
Ensure brevity in your answer.  0.61. What is the ratio of the Losses(% of output) in Morocco in 1992 to that in 1994?
Your answer should be compact. 0.35. What is the ratio of the Losses(% of output) of Haiti in 1993 to that in 1994?
Your response must be concise. 0.84. What is the ratio of the Losses(% of output) in Morocco in 1993 to that in 1994?
Keep it short and to the point. 0.47. What is the difference between the highest and the second highest Losses(% of output) in Colombia?
Your answer should be very brief. 0.46. What is the difference between the highest and the second highest Losses(% of output) in Haiti?
Your answer should be very brief. 7.98. What is the difference between the highest and the lowest Losses(% of output) of Colombia?
Your answer should be very brief. 3.24. What is the difference between the highest and the lowest Losses(% of output) in Haiti?
Offer a very short reply. 20.32. What is the difference between the highest and the lowest Losses(% of output) of Morocco?
Provide a short and direct response. 6.21. 